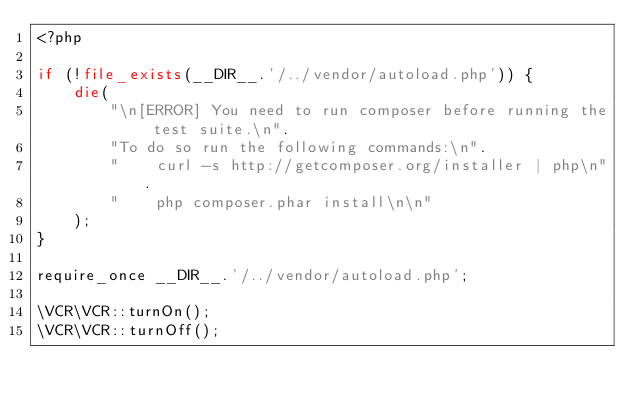Convert code to text. <code><loc_0><loc_0><loc_500><loc_500><_PHP_><?php

if (!file_exists(__DIR__.'/../vendor/autoload.php')) {
    die(
        "\n[ERROR] You need to run composer before running the test suite.\n".
        "To do so run the following commands:\n".
        "    curl -s http://getcomposer.org/installer | php\n".
        "    php composer.phar install\n\n"
    );
}

require_once __DIR__.'/../vendor/autoload.php';

\VCR\VCR::turnOn();
\VCR\VCR::turnOff();
</code> 